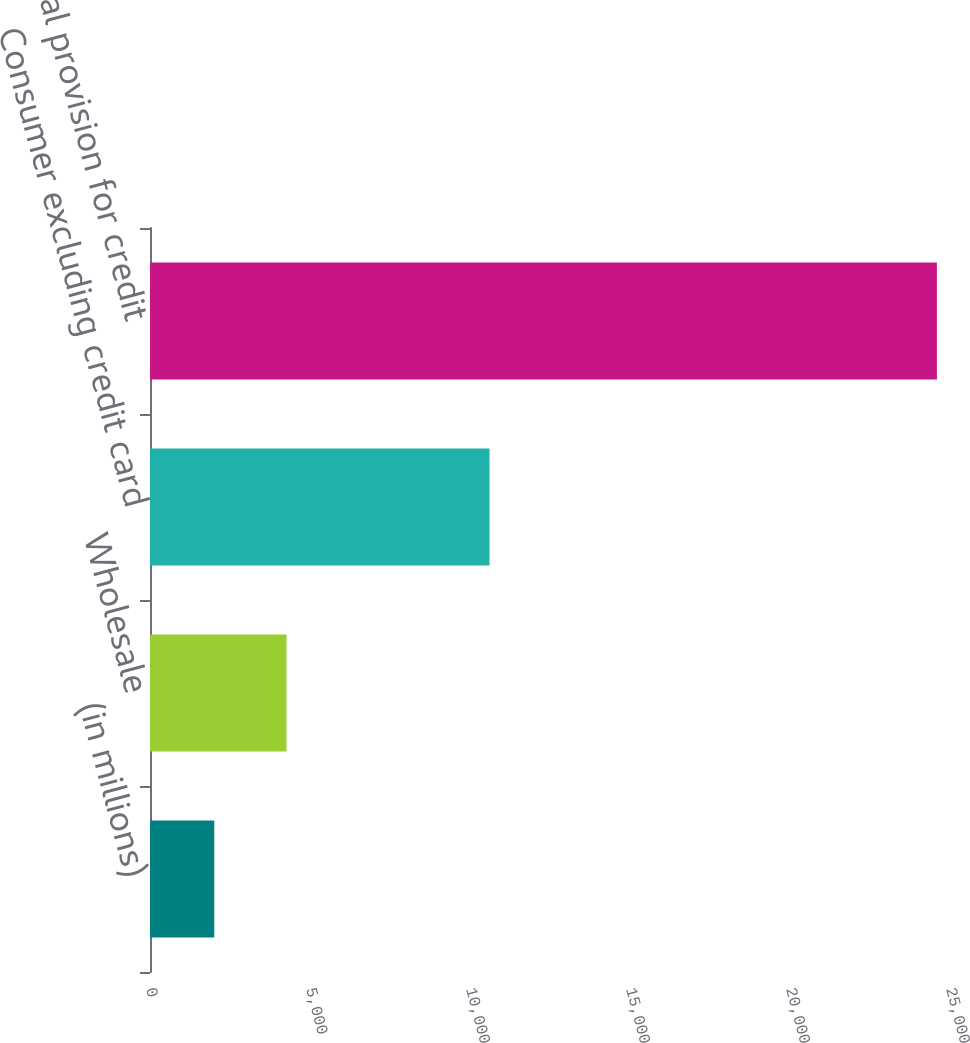Convert chart. <chart><loc_0><loc_0><loc_500><loc_500><bar_chart><fcel>(in millions)<fcel>Wholesale<fcel>Consumer excluding credit card<fcel>Total provision for credit<nl><fcel>2008<fcel>4266.3<fcel>10610<fcel>24591<nl></chart> 